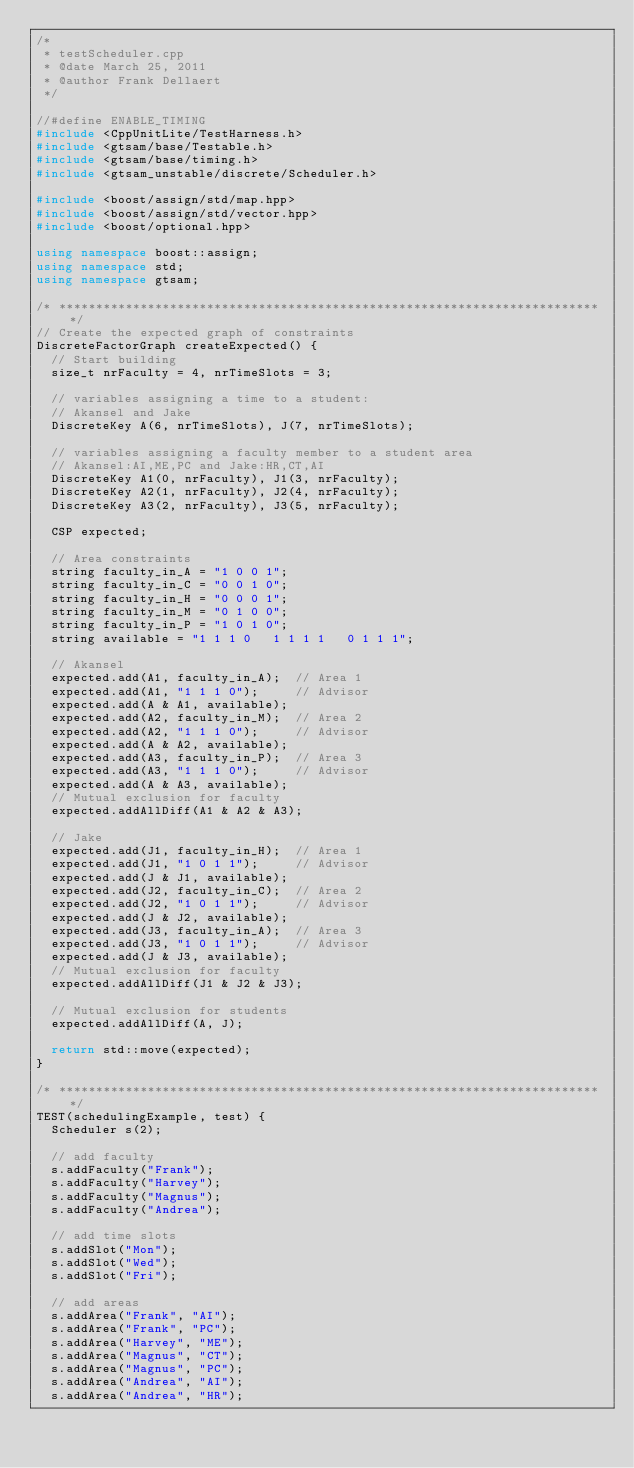Convert code to text. <code><loc_0><loc_0><loc_500><loc_500><_C++_>/*
 * testScheduler.cpp
 * @date March 25, 2011
 * @author Frank Dellaert
 */

//#define ENABLE_TIMING
#include <CppUnitLite/TestHarness.h>
#include <gtsam/base/Testable.h>
#include <gtsam/base/timing.h>
#include <gtsam_unstable/discrete/Scheduler.h>

#include <boost/assign/std/map.hpp>
#include <boost/assign/std/vector.hpp>
#include <boost/optional.hpp>

using namespace boost::assign;
using namespace std;
using namespace gtsam;

/* ************************************************************************* */
// Create the expected graph of constraints
DiscreteFactorGraph createExpected() {
  // Start building
  size_t nrFaculty = 4, nrTimeSlots = 3;

  // variables assigning a time to a student:
  // Akansel and Jake
  DiscreteKey A(6, nrTimeSlots), J(7, nrTimeSlots);

  // variables assigning a faculty member to a student area
  // Akansel:AI,ME,PC and Jake:HR,CT,AI
  DiscreteKey A1(0, nrFaculty), J1(3, nrFaculty);
  DiscreteKey A2(1, nrFaculty), J2(4, nrFaculty);
  DiscreteKey A3(2, nrFaculty), J3(5, nrFaculty);

  CSP expected;

  // Area constraints
  string faculty_in_A = "1 0 0 1";
  string faculty_in_C = "0 0 1 0";
  string faculty_in_H = "0 0 0 1";
  string faculty_in_M = "0 1 0 0";
  string faculty_in_P = "1 0 1 0";
  string available = "1 1 1 0   1 1 1 1   0 1 1 1";

  // Akansel
  expected.add(A1, faculty_in_A);  // Area 1
  expected.add(A1, "1 1 1 0");     // Advisor
  expected.add(A & A1, available);
  expected.add(A2, faculty_in_M);  // Area 2
  expected.add(A2, "1 1 1 0");     // Advisor
  expected.add(A & A2, available);
  expected.add(A3, faculty_in_P);  // Area 3
  expected.add(A3, "1 1 1 0");     // Advisor
  expected.add(A & A3, available);
  // Mutual exclusion for faculty
  expected.addAllDiff(A1 & A2 & A3);

  // Jake
  expected.add(J1, faculty_in_H);  // Area 1
  expected.add(J1, "1 0 1 1");     // Advisor
  expected.add(J & J1, available);
  expected.add(J2, faculty_in_C);  // Area 2
  expected.add(J2, "1 0 1 1");     // Advisor
  expected.add(J & J2, available);
  expected.add(J3, faculty_in_A);  // Area 3
  expected.add(J3, "1 0 1 1");     // Advisor
  expected.add(J & J3, available);
  // Mutual exclusion for faculty
  expected.addAllDiff(J1 & J2 & J3);

  // Mutual exclusion for students
  expected.addAllDiff(A, J);

  return std::move(expected);
}

/* ************************************************************************* */
TEST(schedulingExample, test) {
  Scheduler s(2);

  // add faculty
  s.addFaculty("Frank");
  s.addFaculty("Harvey");
  s.addFaculty("Magnus");
  s.addFaculty("Andrea");

  // add time slots
  s.addSlot("Mon");
  s.addSlot("Wed");
  s.addSlot("Fri");

  // add areas
  s.addArea("Frank", "AI");
  s.addArea("Frank", "PC");
  s.addArea("Harvey", "ME");
  s.addArea("Magnus", "CT");
  s.addArea("Magnus", "PC");
  s.addArea("Andrea", "AI");
  s.addArea("Andrea", "HR");
</code> 